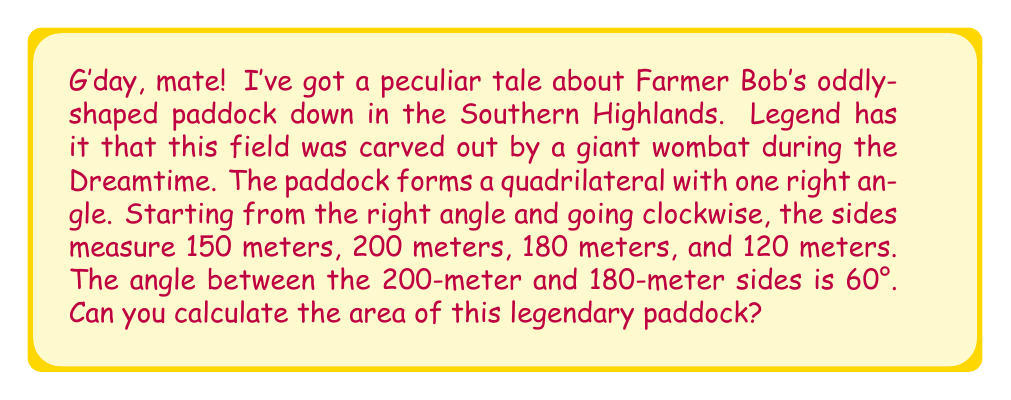Teach me how to tackle this problem. Let's approach this step-by-step using trigonometry:

1) We can split this quadrilateral into two triangles by drawing a diagonal from the right angle to the opposite corner.

2) Let's call the right-angled corner A, and label the other corners B, C, and D in clockwise order.

3) We know all sides of triangle ABC:
   AB = 150 m, BC = 200 m, AC (diagonal) unknown

4) In triangle ACD:
   AD = 120 m, CD = 180 m, AC (same diagonal) unknown, angle ACD = 60°

5) Let's find AC using the cosine rule in triangle ACD:
   $$AC^2 = 120^2 + 180^2 - 2(120)(180)\cos(60°)$$
   $$AC^2 = 14400 + 32400 - 43200(0.5) = 25200$$
   $$AC = \sqrt{25200} = 10\sqrt{252} \approx 158.75 \text{ m}$$

6) Now we can find the areas of both triangles:
   Area of ABC = $\frac{1}{2} \times 150 \times 200 = 15000 \text{ m}^2$
   
   Area of ACD = $\frac{1}{2} \times 120 \times 180 \times \sin(60°) = 10392 \text{ m}^2$

7) The total area is the sum of these two triangles:
   Total Area = 15000 + 10392 = 25392 m²
Answer: 25392 m² 